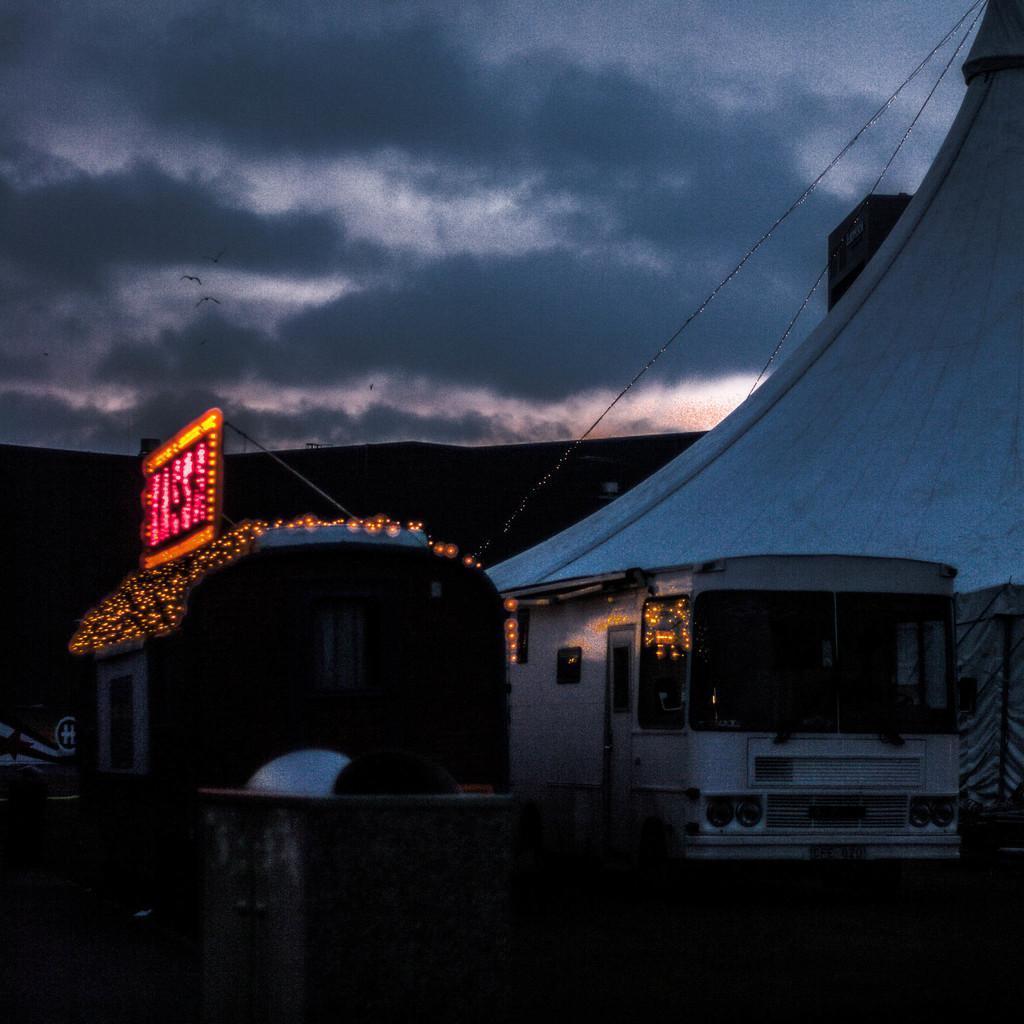Please provide a concise description of this image. In the image we can see the vehicle and these are the headlights of the vehicle. Here we can see led board, small lights and the cloudy sky. 